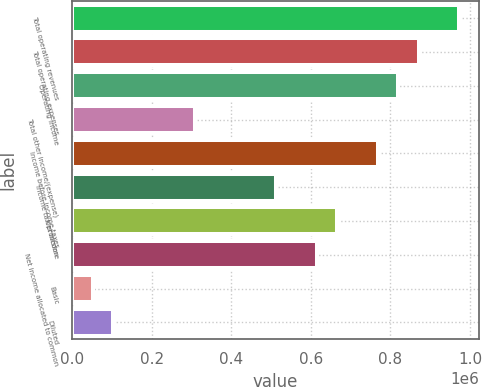<chart> <loc_0><loc_0><loc_500><loc_500><bar_chart><fcel>Total operating revenues<fcel>Total operating expenses<fcel>Operating income<fcel>Total other income/(expense)<fcel>Income before income taxes<fcel>Income tax provision<fcel>Net income<fcel>Net income allocated to common<fcel>Basic<fcel>Diluted<nl><fcel>973441<fcel>870974<fcel>819740<fcel>307403<fcel>768506<fcel>512338<fcel>666039<fcel>614805<fcel>51235<fcel>102469<nl></chart> 